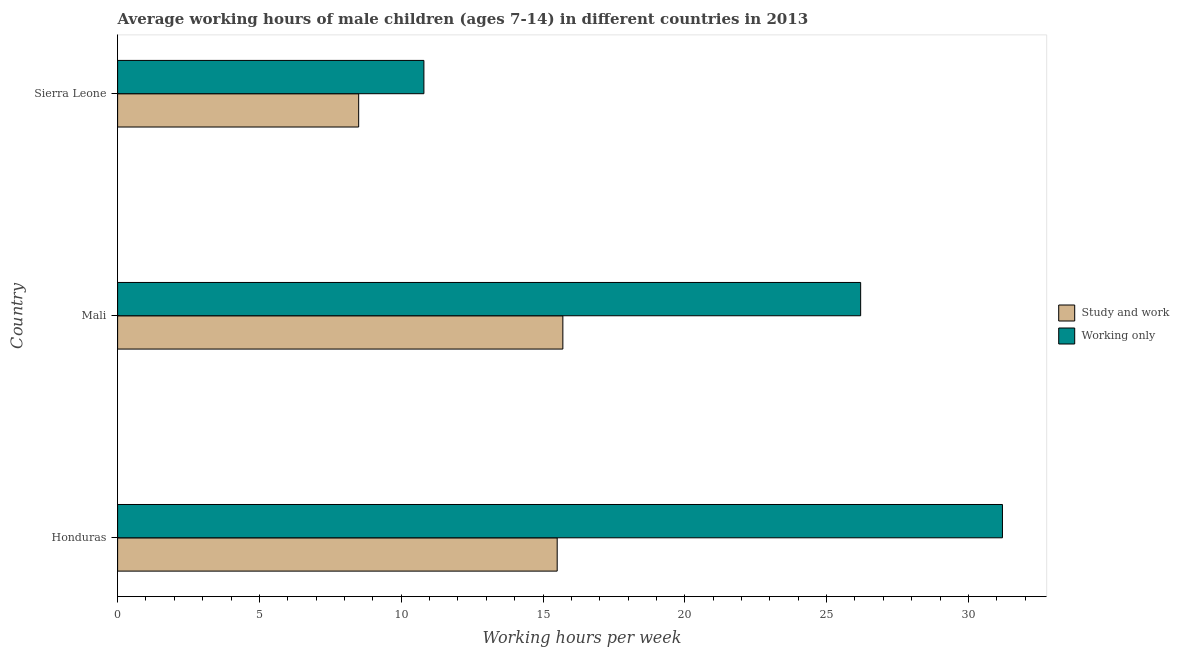How many different coloured bars are there?
Keep it short and to the point. 2. Are the number of bars on each tick of the Y-axis equal?
Provide a short and direct response. Yes. How many bars are there on the 2nd tick from the top?
Your response must be concise. 2. What is the label of the 3rd group of bars from the top?
Ensure brevity in your answer.  Honduras. What is the average working hour of children involved in study and work in Mali?
Provide a succinct answer. 15.7. Across all countries, what is the maximum average working hour of children involved in only work?
Your answer should be compact. 31.2. In which country was the average working hour of children involved in only work maximum?
Offer a very short reply. Honduras. In which country was the average working hour of children involved in study and work minimum?
Your answer should be compact. Sierra Leone. What is the total average working hour of children involved in study and work in the graph?
Give a very brief answer. 39.7. What is the difference between the average working hour of children involved in study and work in Mali and the average working hour of children involved in only work in Sierra Leone?
Offer a terse response. 4.9. What is the average average working hour of children involved in study and work per country?
Provide a succinct answer. 13.23. What is the difference between the average working hour of children involved in study and work and average working hour of children involved in only work in Honduras?
Provide a short and direct response. -15.7. In how many countries, is the average working hour of children involved in only work greater than 16 hours?
Give a very brief answer. 2. What is the ratio of the average working hour of children involved in only work in Honduras to that in Sierra Leone?
Offer a terse response. 2.89. Is the average working hour of children involved in study and work in Honduras less than that in Sierra Leone?
Offer a terse response. No. Is the difference between the average working hour of children involved in only work in Honduras and Mali greater than the difference between the average working hour of children involved in study and work in Honduras and Mali?
Provide a succinct answer. Yes. What is the difference between the highest and the second highest average working hour of children involved in only work?
Offer a terse response. 5. In how many countries, is the average working hour of children involved in only work greater than the average average working hour of children involved in only work taken over all countries?
Ensure brevity in your answer.  2. Is the sum of the average working hour of children involved in only work in Mali and Sierra Leone greater than the maximum average working hour of children involved in study and work across all countries?
Provide a succinct answer. Yes. What does the 1st bar from the top in Sierra Leone represents?
Your answer should be compact. Working only. What does the 2nd bar from the bottom in Sierra Leone represents?
Your response must be concise. Working only. How many bars are there?
Offer a very short reply. 6. What is the title of the graph?
Offer a very short reply. Average working hours of male children (ages 7-14) in different countries in 2013. Does "Infant" appear as one of the legend labels in the graph?
Your answer should be very brief. No. What is the label or title of the X-axis?
Provide a succinct answer. Working hours per week. What is the label or title of the Y-axis?
Make the answer very short. Country. What is the Working hours per week of Working only in Honduras?
Your response must be concise. 31.2. What is the Working hours per week in Working only in Mali?
Offer a very short reply. 26.2. What is the Working hours per week in Working only in Sierra Leone?
Your answer should be very brief. 10.8. Across all countries, what is the maximum Working hours per week of Study and work?
Your answer should be compact. 15.7. Across all countries, what is the maximum Working hours per week of Working only?
Your response must be concise. 31.2. What is the total Working hours per week of Study and work in the graph?
Provide a short and direct response. 39.7. What is the total Working hours per week of Working only in the graph?
Provide a succinct answer. 68.2. What is the difference between the Working hours per week in Study and work in Honduras and that in Mali?
Make the answer very short. -0.2. What is the difference between the Working hours per week of Working only in Honduras and that in Mali?
Your response must be concise. 5. What is the difference between the Working hours per week in Working only in Honduras and that in Sierra Leone?
Keep it short and to the point. 20.4. What is the difference between the Working hours per week in Study and work in Mali and that in Sierra Leone?
Provide a succinct answer. 7.2. What is the difference between the Working hours per week of Study and work in Mali and the Working hours per week of Working only in Sierra Leone?
Make the answer very short. 4.9. What is the average Working hours per week of Study and work per country?
Your response must be concise. 13.23. What is the average Working hours per week of Working only per country?
Your answer should be very brief. 22.73. What is the difference between the Working hours per week in Study and work and Working hours per week in Working only in Honduras?
Offer a terse response. -15.7. What is the ratio of the Working hours per week of Study and work in Honduras to that in Mali?
Give a very brief answer. 0.99. What is the ratio of the Working hours per week of Working only in Honduras to that in Mali?
Make the answer very short. 1.19. What is the ratio of the Working hours per week in Study and work in Honduras to that in Sierra Leone?
Your response must be concise. 1.82. What is the ratio of the Working hours per week in Working only in Honduras to that in Sierra Leone?
Give a very brief answer. 2.89. What is the ratio of the Working hours per week in Study and work in Mali to that in Sierra Leone?
Ensure brevity in your answer.  1.85. What is the ratio of the Working hours per week in Working only in Mali to that in Sierra Leone?
Provide a short and direct response. 2.43. What is the difference between the highest and the second highest Working hours per week of Study and work?
Provide a succinct answer. 0.2. What is the difference between the highest and the lowest Working hours per week of Study and work?
Provide a succinct answer. 7.2. What is the difference between the highest and the lowest Working hours per week in Working only?
Provide a succinct answer. 20.4. 